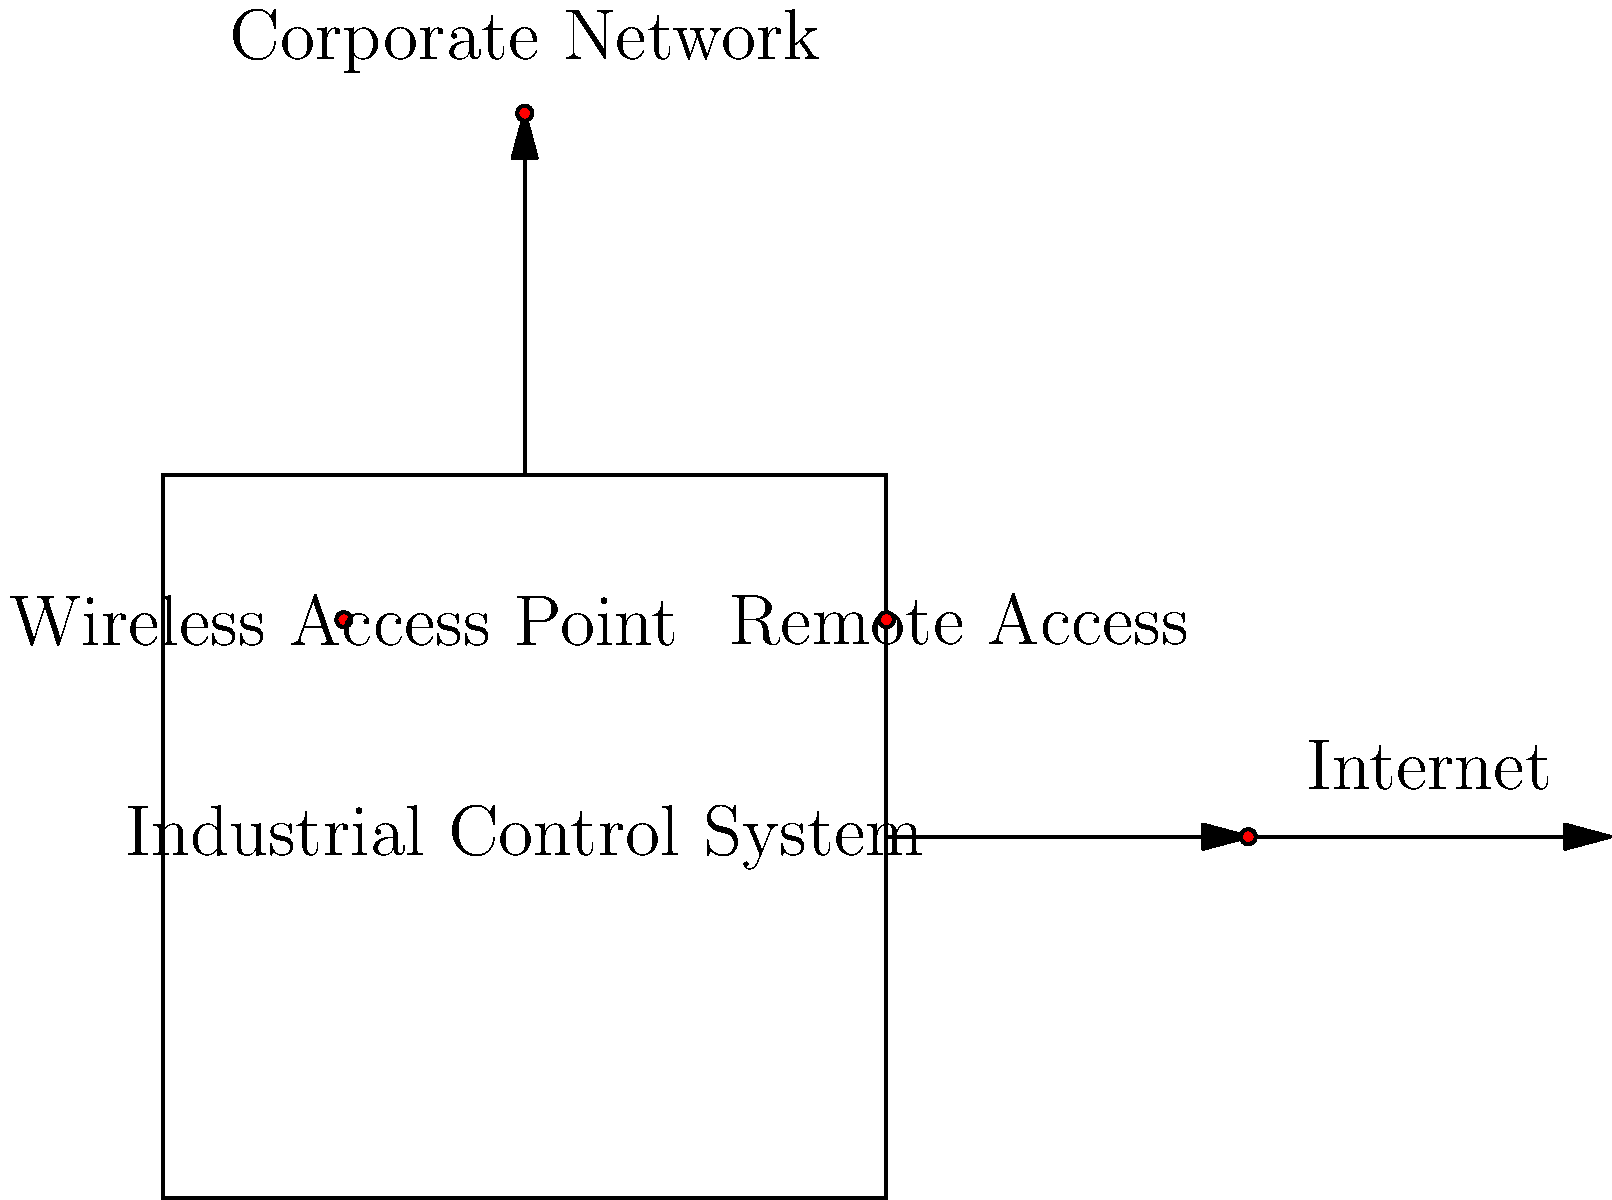Identify the number of potential entry points for cyber attacks in the given industrial control system diagram. Each red dot represents a potential entry point. To identify the number of potential entry points for cyber attacks in the industrial control system diagram, we need to follow these steps:

1. Examine the diagram for red dots, which represent potential entry points.
2. Count each red dot:
   a. Internet connection: 1 red dot
   b. Corporate Network connection: 1 red dot
   c. Remote Access point: 1 red dot
   d. Wireless Access Point: 1 red dot

3. Sum up the total number of red dots:
   $$1 + 1 + 1 + 1 = 4$$

Therefore, there are 4 potential entry points for cyber attacks in the given industrial control system diagram.

These entry points represent common vulnerabilities in industrial control systems:
1. Internet connection: Potential for external attacks
2. Corporate Network connection: Possible lateral movement from compromised office systems
3. Remote Access: Vulnerabilities in remote connection protocols or weak authentication
4. Wireless Access Point: Potential for unauthorized access or man-in-the-middle attacks

Each of these points requires specific security measures to mitigate potential cyber threats.
Answer: 4 